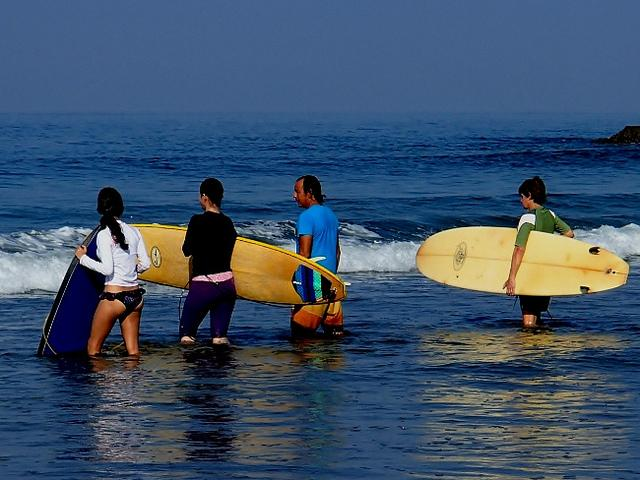What type of surfboard does the woman with the black pants have? large 